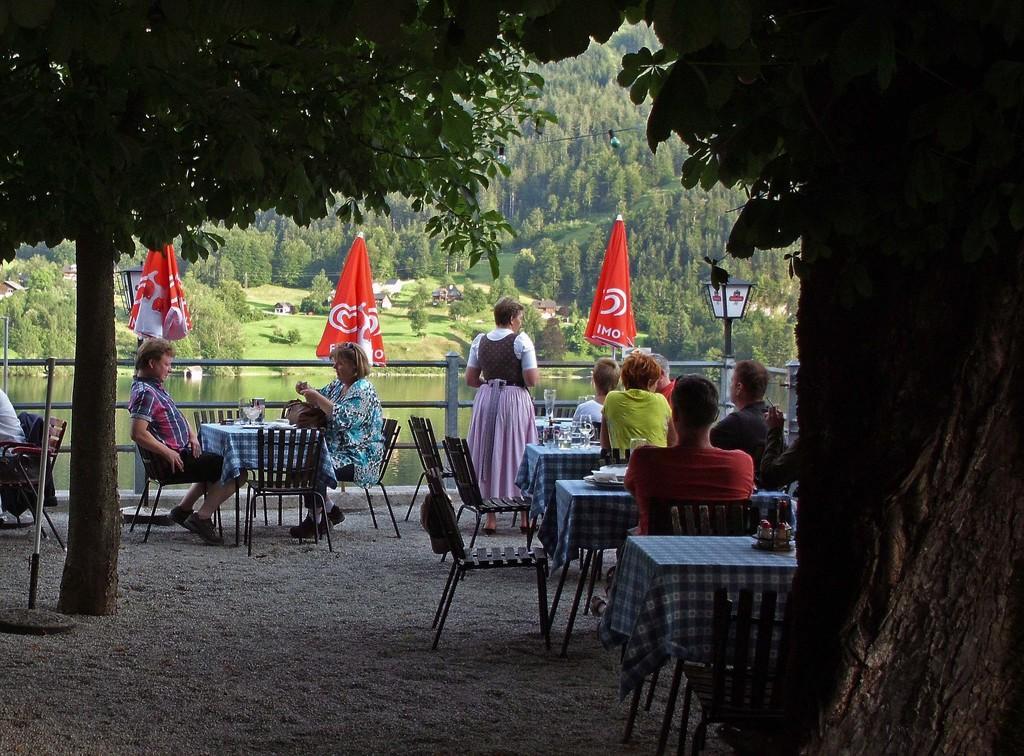Could you give a brief overview of what you see in this image? On the background we can see trees, grass , plants. This is a lake. here we can see red colour umbrellas and a fence. We can see persons sitting on chairs in front of a table and on the table we can see glasses. We can see one woman standing near to the table. This is a branch. 